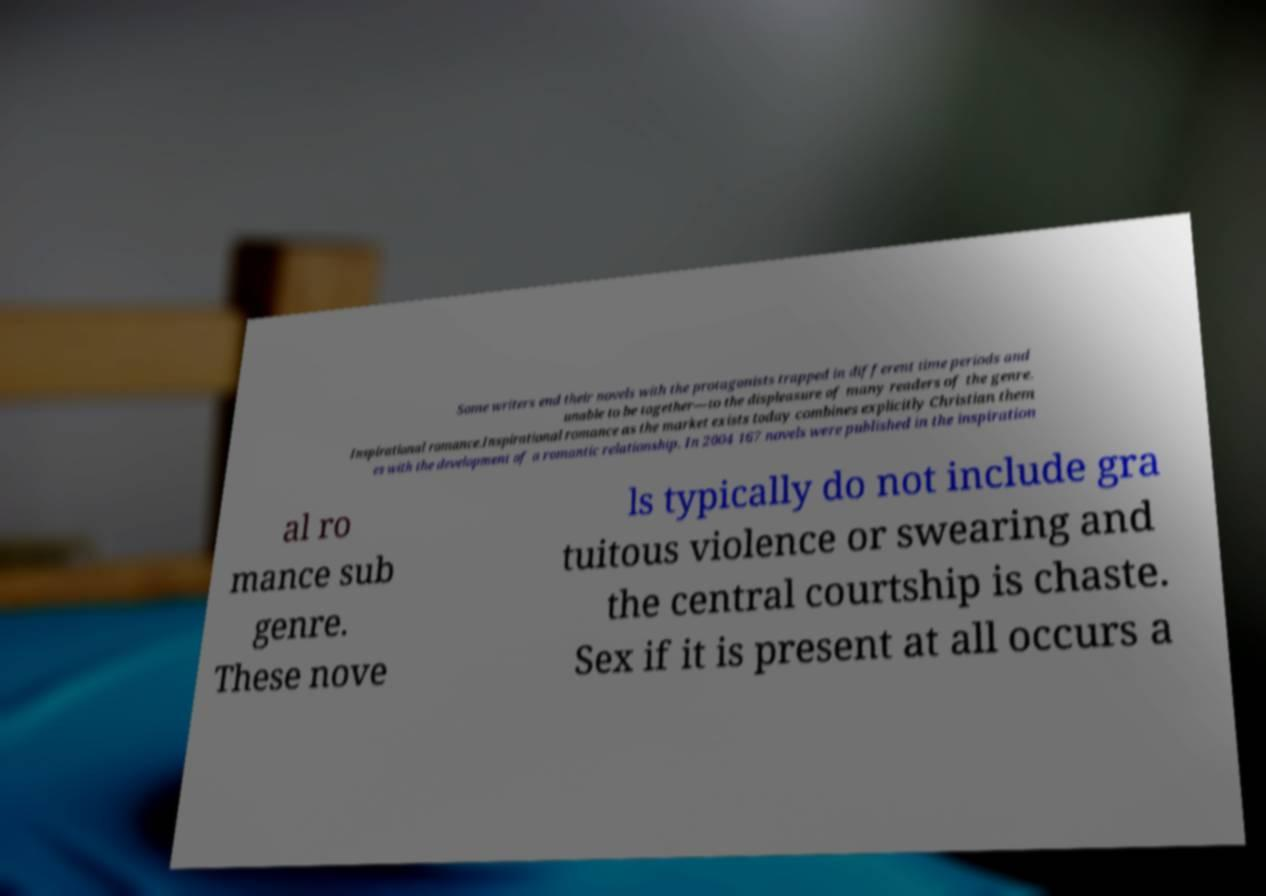What messages or text are displayed in this image? I need them in a readable, typed format. Some writers end their novels with the protagonists trapped in different time periods and unable to be together—to the displeasure of many readers of the genre. Inspirational romance.Inspirational romance as the market exists today combines explicitly Christian them es with the development of a romantic relationship. In 2004 167 novels were published in the inspiration al ro mance sub genre. These nove ls typically do not include gra tuitous violence or swearing and the central courtship is chaste. Sex if it is present at all occurs a 